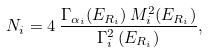<formula> <loc_0><loc_0><loc_500><loc_500>N _ { i } = 4 \, \frac { \Gamma _ { \alpha _ { i } } ( E _ { R _ { i } } ) \, M _ { i } ^ { 2 } ( E _ { R _ { i } } ) } { \Gamma _ { i } ^ { 2 } \, ( E _ { R _ { i } } ) } ,</formula> 